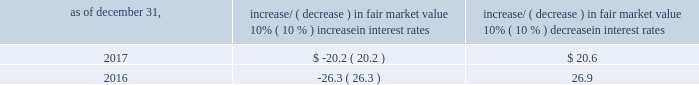Item 7a .
Quantitative and qualitative disclosures about market risk ( amounts in millions ) in the normal course of business , we are exposed to market risks related to interest rates , foreign currency rates and certain balance sheet items .
From time to time , we use derivative instruments , pursuant to established guidelines and policies , to manage some portion of these risks .
Derivative instruments utilized in our hedging activities are viewed as risk management tools and are not used for trading or speculative purposes .
Interest rates our exposure to market risk for changes in interest rates relates primarily to the fair market value and cash flows of our debt obligations .
The majority of our debt ( approximately 94% ( 94 % ) and 93% ( 93 % ) as of december 31 , 2017 and 2016 , respectively ) bears interest at fixed rates .
We do have debt with variable interest rates , but a 10% ( 10 % ) increase or decrease in interest rates would not be material to our interest expense or cash flows .
The fair market value of our debt is sensitive to changes in interest rates , and the impact of a 10% ( 10 % ) change in interest rates is summarized below .
Increase/ ( decrease ) in fair market value as of december 31 , 10% ( 10 % ) increase in interest rates 10% ( 10 % ) decrease in interest rates .
We have used interest rate swaps for risk management purposes to manage our exposure to changes in interest rates .
We did not have any interest rate swaps outstanding as of december 31 , 2017 .
We had $ 791.0 of cash , cash equivalents and marketable securities as of december 31 , 2017 that we generally invest in conservative , short-term bank deposits or securities .
The interest income generated from these investments is subject to both domestic and foreign interest rate movements .
During 2017 and 2016 , we had interest income of $ 19.4 and $ 20.1 , respectively .
Based on our 2017 results , a 100 basis-point increase or decrease in interest rates would affect our interest income by approximately $ 7.9 , assuming that all cash , cash equivalents and marketable securities are impacted in the same manner and balances remain constant from year-end 2017 levels .
Foreign currency rates we are subject to translation and transaction risks related to changes in foreign currency exchange rates .
Since we report revenues and expenses in u.s .
Dollars , changes in exchange rates may either positively or negatively affect our consolidated revenues and expenses ( as expressed in u.s .
Dollars ) from foreign operations .
The foreign currencies that most impacted our results during 2017 included the british pound sterling and , to a lesser extent , brazilian real and south african rand .
Based on 2017 exchange rates and operating results , if the u.s .
Dollar were to strengthen or weaken by 10% ( 10 % ) , we currently estimate operating income would decrease or increase approximately 4% ( 4 % ) , assuming that all currencies are impacted in the same manner and our international revenue and expenses remain constant at 2017 levels .
The functional currency of our foreign operations is generally their respective local currency .
Assets and liabilities are translated at the exchange rates in effect at the balance sheet date , and revenues and expenses are translated at the average exchange rates during the period presented .
The resulting translation adjustments are recorded as a component of accumulated other comprehensive loss , net of tax , in the stockholders 2019 equity section of our consolidated balance sheets .
Our foreign subsidiaries generally collect revenues and pay expenses in their functional currency , mitigating transaction risk .
However , certain subsidiaries may enter into transactions in currencies other than their functional currency .
Assets and liabilities denominated in currencies other than the functional currency are susceptible to movements in foreign currency until final settlement .
Currency transaction gains or losses primarily arising from transactions in currencies other than the functional currency are included in office and general expenses .
We regularly review our foreign exchange exposures that may have a material impact on our business and from time to time use foreign currency forward exchange contracts or other derivative financial instruments to hedge the effects of potential adverse fluctuations in foreign currency exchange rates arising from these exposures .
We do not enter into foreign exchange contracts or other derivatives for speculative purposes. .
What is the difference of the debt market value between 2016 and 2017 if interest rates decrease 10%? 
Computations: (20.6 - 26.9)
Answer: -6.3. 